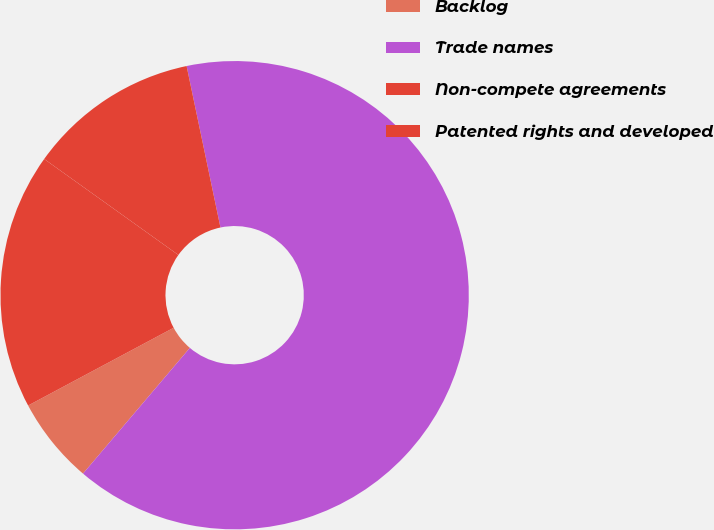Convert chart. <chart><loc_0><loc_0><loc_500><loc_500><pie_chart><fcel>Backlog<fcel>Trade names<fcel>Non-compete agreements<fcel>Patented rights and developed<nl><fcel>5.98%<fcel>64.5%<fcel>11.83%<fcel>17.69%<nl></chart> 